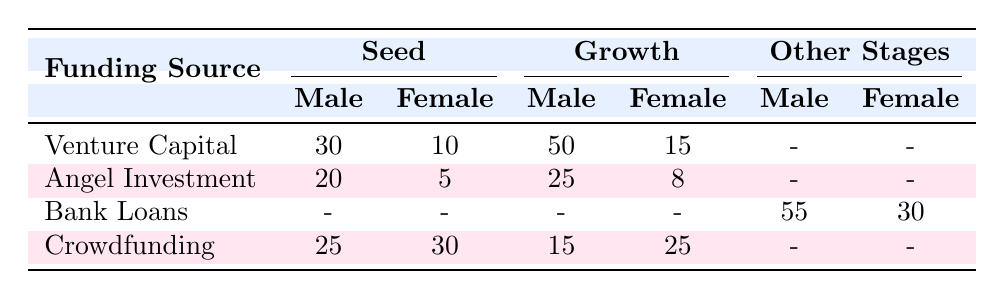What is the total number of male entrepreneurs in Seed stage for Angel Investment? According to the table, the number of male entrepreneurs in Seed stage for Angel Investment is 20.
Answer: 20 How many female entrepreneurs received Bank Loans at the Established stage? The table shows that there are 10 female entrepreneurs who received Bank Loans at the Established stage.
Answer: 10 What is the difference in the number of male entrepreneurs between the Growth stage and the Seed stage for Venture Capital? The number of male entrepreneurs in the Growth stage for Venture Capital is 50, while in the Seed stage it is 30. The difference is 50 - 30 = 20.
Answer: 20 Are there more female entrepreneurs in Crowdfunding at the Seed stage than in the Growth stage? In the Seed stage for Crowdfunding, there are 30 female entrepreneurs, while in the Growth stage there are 25. Since 30 is greater than 25, the answer is yes.
Answer: Yes What is the total number of female entrepreneurs across all funding sources in the Seed stage? From the table, we sum the female entrepreneurs in Seed stage: 10 (Venture Capital) + 5 (Angel Investment) + 30 (Crowdfunding) = 45.
Answer: 45 How many male entrepreneurs received Angel Investment in total across both stages? The number of male entrepreneurs in Angel Investment Seed stage is 20, and in Growth stage, it is 25. The total is 20 + 25 = 45.
Answer: 45 Is the number of male entrepreneurs in Crowdfunding Growth stage greater than the number in Venture Capital Seed stage? For Crowdfunding in the Growth stage, there are 15 male entrepreneurs and for Venture Capital in the Seed stage, there are 30. Since 15 is not greater than 30, the answer is no.
Answer: No What is the overall ratio of male to female entrepreneurs in Bank Loans across all stages? From the table, for Bank Loans: Total male is 55 and total female is 30. The ratio is 55:30, which simplifies to 11:6.
Answer: 11:6 How many more male entrepreneurs are there in Venture Capital Growth stage compared to Angel Investment Growth stage? The number of male entrepreneurs in Venture Capital Growth stage is 50, and in Angel Investment Growth stage, it is 25. The difference is 50 - 25 = 25.
Answer: 25 